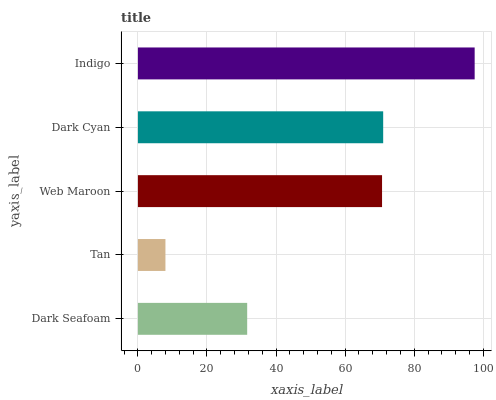Is Tan the minimum?
Answer yes or no. Yes. Is Indigo the maximum?
Answer yes or no. Yes. Is Web Maroon the minimum?
Answer yes or no. No. Is Web Maroon the maximum?
Answer yes or no. No. Is Web Maroon greater than Tan?
Answer yes or no. Yes. Is Tan less than Web Maroon?
Answer yes or no. Yes. Is Tan greater than Web Maroon?
Answer yes or no. No. Is Web Maroon less than Tan?
Answer yes or no. No. Is Web Maroon the high median?
Answer yes or no. Yes. Is Web Maroon the low median?
Answer yes or no. Yes. Is Dark Seafoam the high median?
Answer yes or no. No. Is Tan the low median?
Answer yes or no. No. 